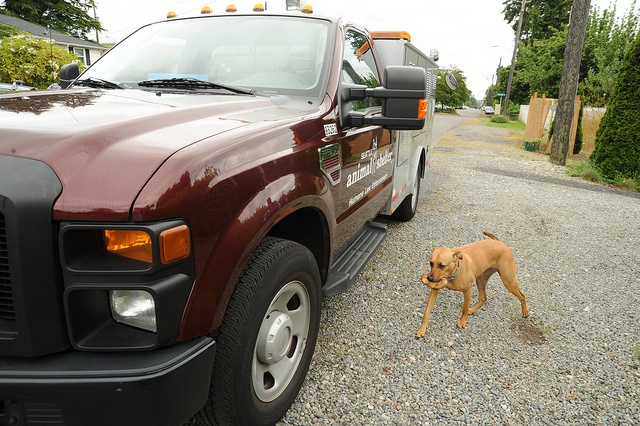Describe the objects in this image and their specific colors. I can see truck in white, black, lightgray, darkgray, and gray tones, dog in white, tan, olive, and maroon tones, and car in white, lightgray, darkgray, gray, and black tones in this image. 